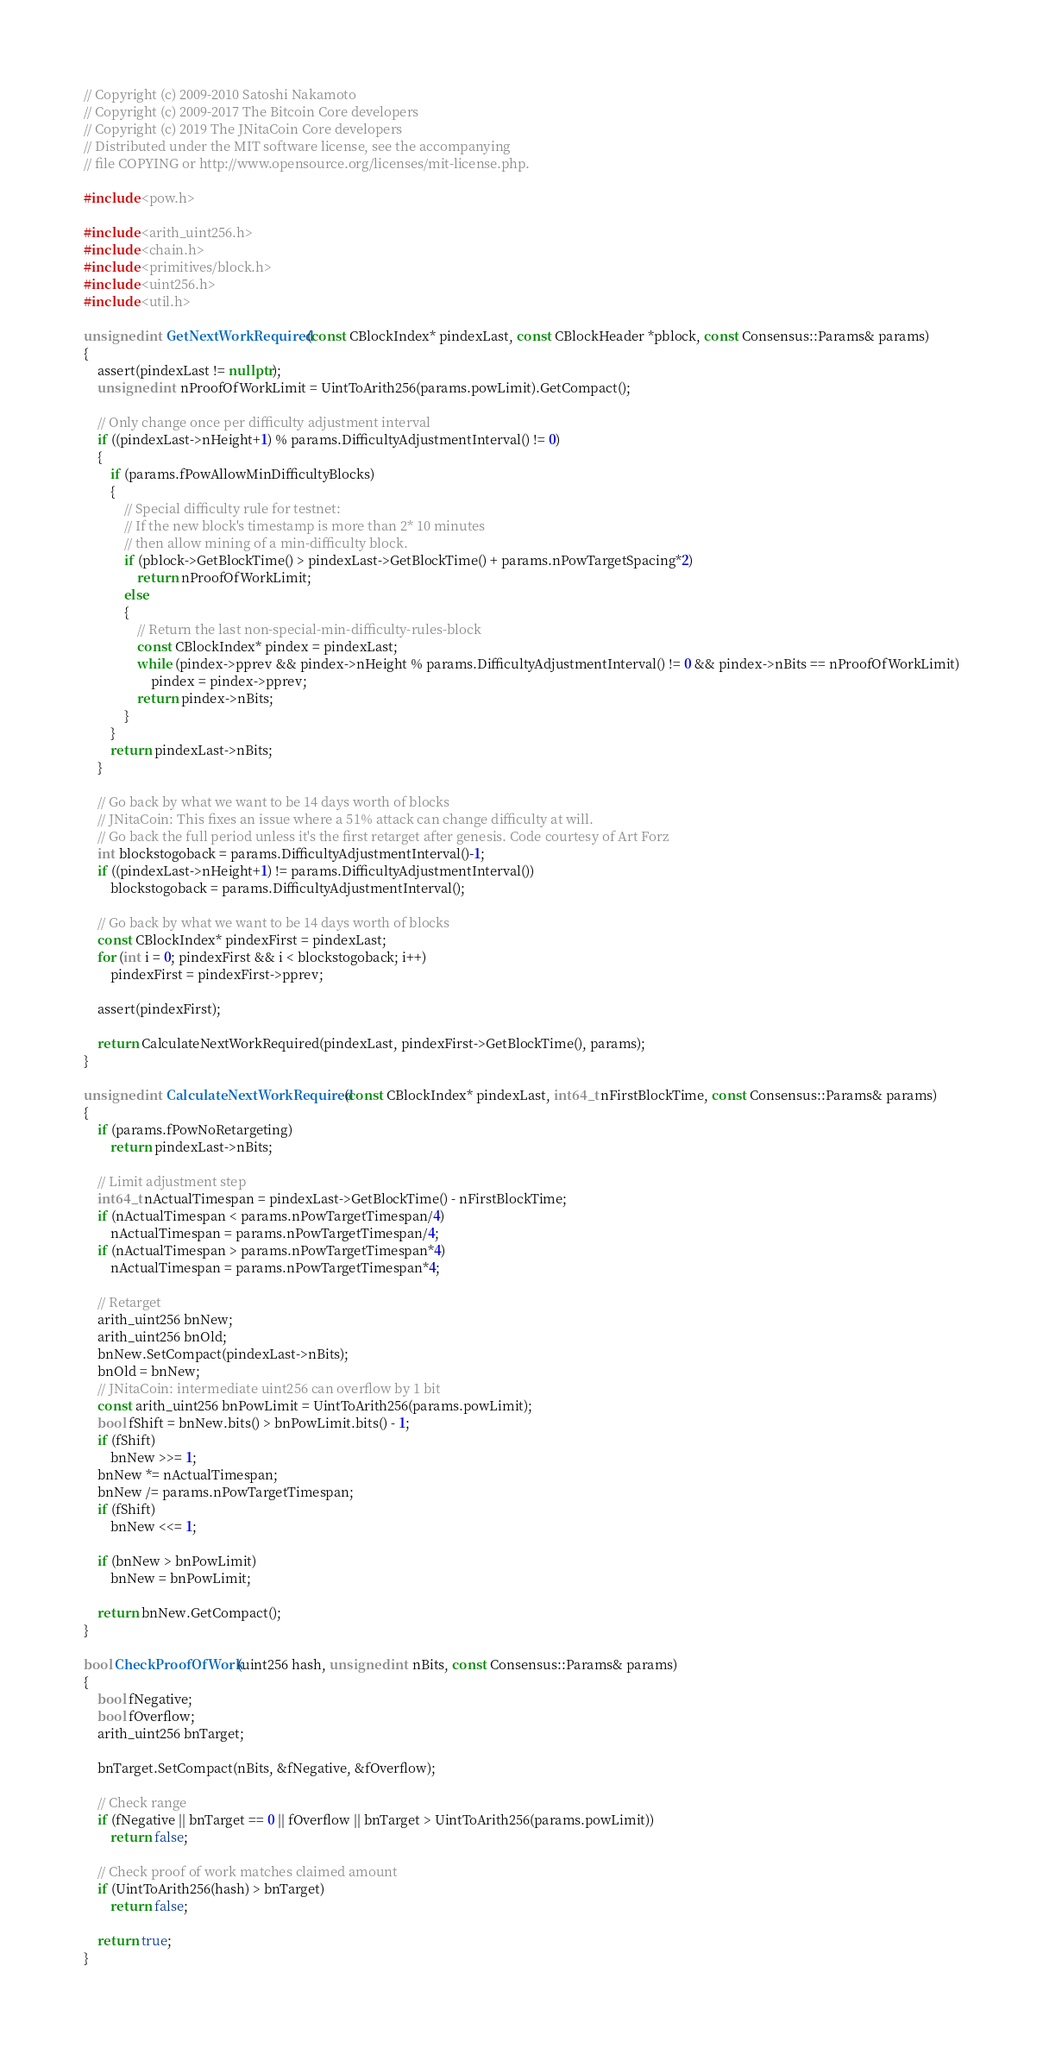<code> <loc_0><loc_0><loc_500><loc_500><_C++_>// Copyright (c) 2009-2010 Satoshi Nakamoto
// Copyright (c) 2009-2017 The Bitcoin Core developers
// Copyright (c) 2019 The JNitaCoin Core developers
// Distributed under the MIT software license, see the accompanying
// file COPYING or http://www.opensource.org/licenses/mit-license.php.

#include <pow.h>

#include <arith_uint256.h>
#include <chain.h>
#include <primitives/block.h>
#include <uint256.h>
#include <util.h>

unsigned int GetNextWorkRequired(const CBlockIndex* pindexLast, const CBlockHeader *pblock, const Consensus::Params& params)
{
    assert(pindexLast != nullptr);
    unsigned int nProofOfWorkLimit = UintToArith256(params.powLimit).GetCompact();

    // Only change once per difficulty adjustment interval
    if ((pindexLast->nHeight+1) % params.DifficultyAdjustmentInterval() != 0)
    {
        if (params.fPowAllowMinDifficultyBlocks)
        {
            // Special difficulty rule for testnet:
            // If the new block's timestamp is more than 2* 10 minutes
            // then allow mining of a min-difficulty block.
            if (pblock->GetBlockTime() > pindexLast->GetBlockTime() + params.nPowTargetSpacing*2)
                return nProofOfWorkLimit;
            else
            {
                // Return the last non-special-min-difficulty-rules-block
                const CBlockIndex* pindex = pindexLast;
                while (pindex->pprev && pindex->nHeight % params.DifficultyAdjustmentInterval() != 0 && pindex->nBits == nProofOfWorkLimit)
                    pindex = pindex->pprev;
                return pindex->nBits;
            }
        }
        return pindexLast->nBits;
    }

    // Go back by what we want to be 14 days worth of blocks
    // JNitaCoin: This fixes an issue where a 51% attack can change difficulty at will.
    // Go back the full period unless it's the first retarget after genesis. Code courtesy of Art Forz
    int blockstogoback = params.DifficultyAdjustmentInterval()-1;
    if ((pindexLast->nHeight+1) != params.DifficultyAdjustmentInterval())
        blockstogoback = params.DifficultyAdjustmentInterval();

    // Go back by what we want to be 14 days worth of blocks
    const CBlockIndex* pindexFirst = pindexLast;
    for (int i = 0; pindexFirst && i < blockstogoback; i++)
        pindexFirst = pindexFirst->pprev;

    assert(pindexFirst);

    return CalculateNextWorkRequired(pindexLast, pindexFirst->GetBlockTime(), params);
}

unsigned int CalculateNextWorkRequired(const CBlockIndex* pindexLast, int64_t nFirstBlockTime, const Consensus::Params& params)
{
    if (params.fPowNoRetargeting)
        return pindexLast->nBits;

    // Limit adjustment step
    int64_t nActualTimespan = pindexLast->GetBlockTime() - nFirstBlockTime;
    if (nActualTimespan < params.nPowTargetTimespan/4)
        nActualTimespan = params.nPowTargetTimespan/4;
    if (nActualTimespan > params.nPowTargetTimespan*4)
        nActualTimespan = params.nPowTargetTimespan*4;

    // Retarget
    arith_uint256 bnNew;
    arith_uint256 bnOld;
    bnNew.SetCompact(pindexLast->nBits);
    bnOld = bnNew;
    // JNitaCoin: intermediate uint256 can overflow by 1 bit
    const arith_uint256 bnPowLimit = UintToArith256(params.powLimit);
    bool fShift = bnNew.bits() > bnPowLimit.bits() - 1;
    if (fShift)
        bnNew >>= 1;
    bnNew *= nActualTimespan;
    bnNew /= params.nPowTargetTimespan;
    if (fShift)
        bnNew <<= 1;

    if (bnNew > bnPowLimit)
        bnNew = bnPowLimit;

    return bnNew.GetCompact();
}

bool CheckProofOfWork(uint256 hash, unsigned int nBits, const Consensus::Params& params)
{
    bool fNegative;
    bool fOverflow;
    arith_uint256 bnTarget;

    bnTarget.SetCompact(nBits, &fNegative, &fOverflow);

    // Check range
    if (fNegative || bnTarget == 0 || fOverflow || bnTarget > UintToArith256(params.powLimit))
        return false;

    // Check proof of work matches claimed amount
    if (UintToArith256(hash) > bnTarget)
        return false;

    return true;
}
</code> 